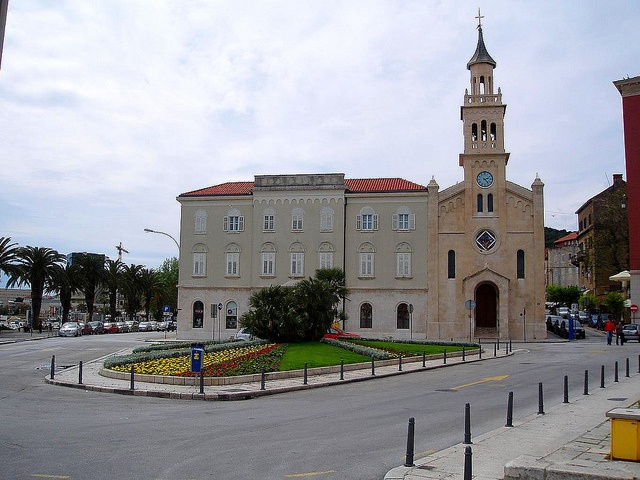Describe the objects in this image and their specific colors. I can see car in black, gray, darkgray, and maroon tones, car in black, gray, and navy tones, car in black, gray, darkgray, and lightgray tones, clock in black and gray tones, and car in black, gray, and blue tones in this image. 